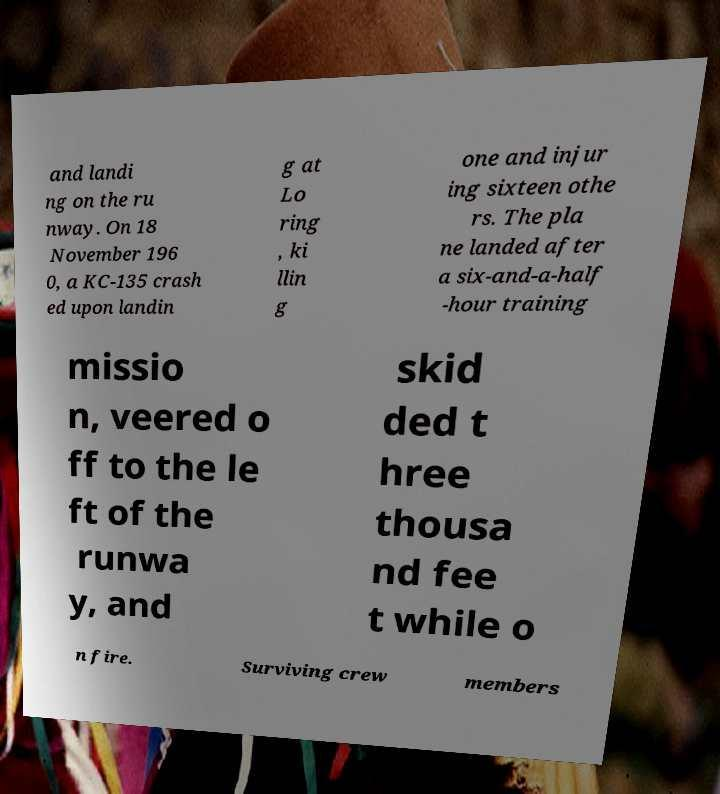For documentation purposes, I need the text within this image transcribed. Could you provide that? and landi ng on the ru nway. On 18 November 196 0, a KC-135 crash ed upon landin g at Lo ring , ki llin g one and injur ing sixteen othe rs. The pla ne landed after a six-and-a-half -hour training missio n, veered o ff to the le ft of the runwa y, and skid ded t hree thousa nd fee t while o n fire. Surviving crew members 